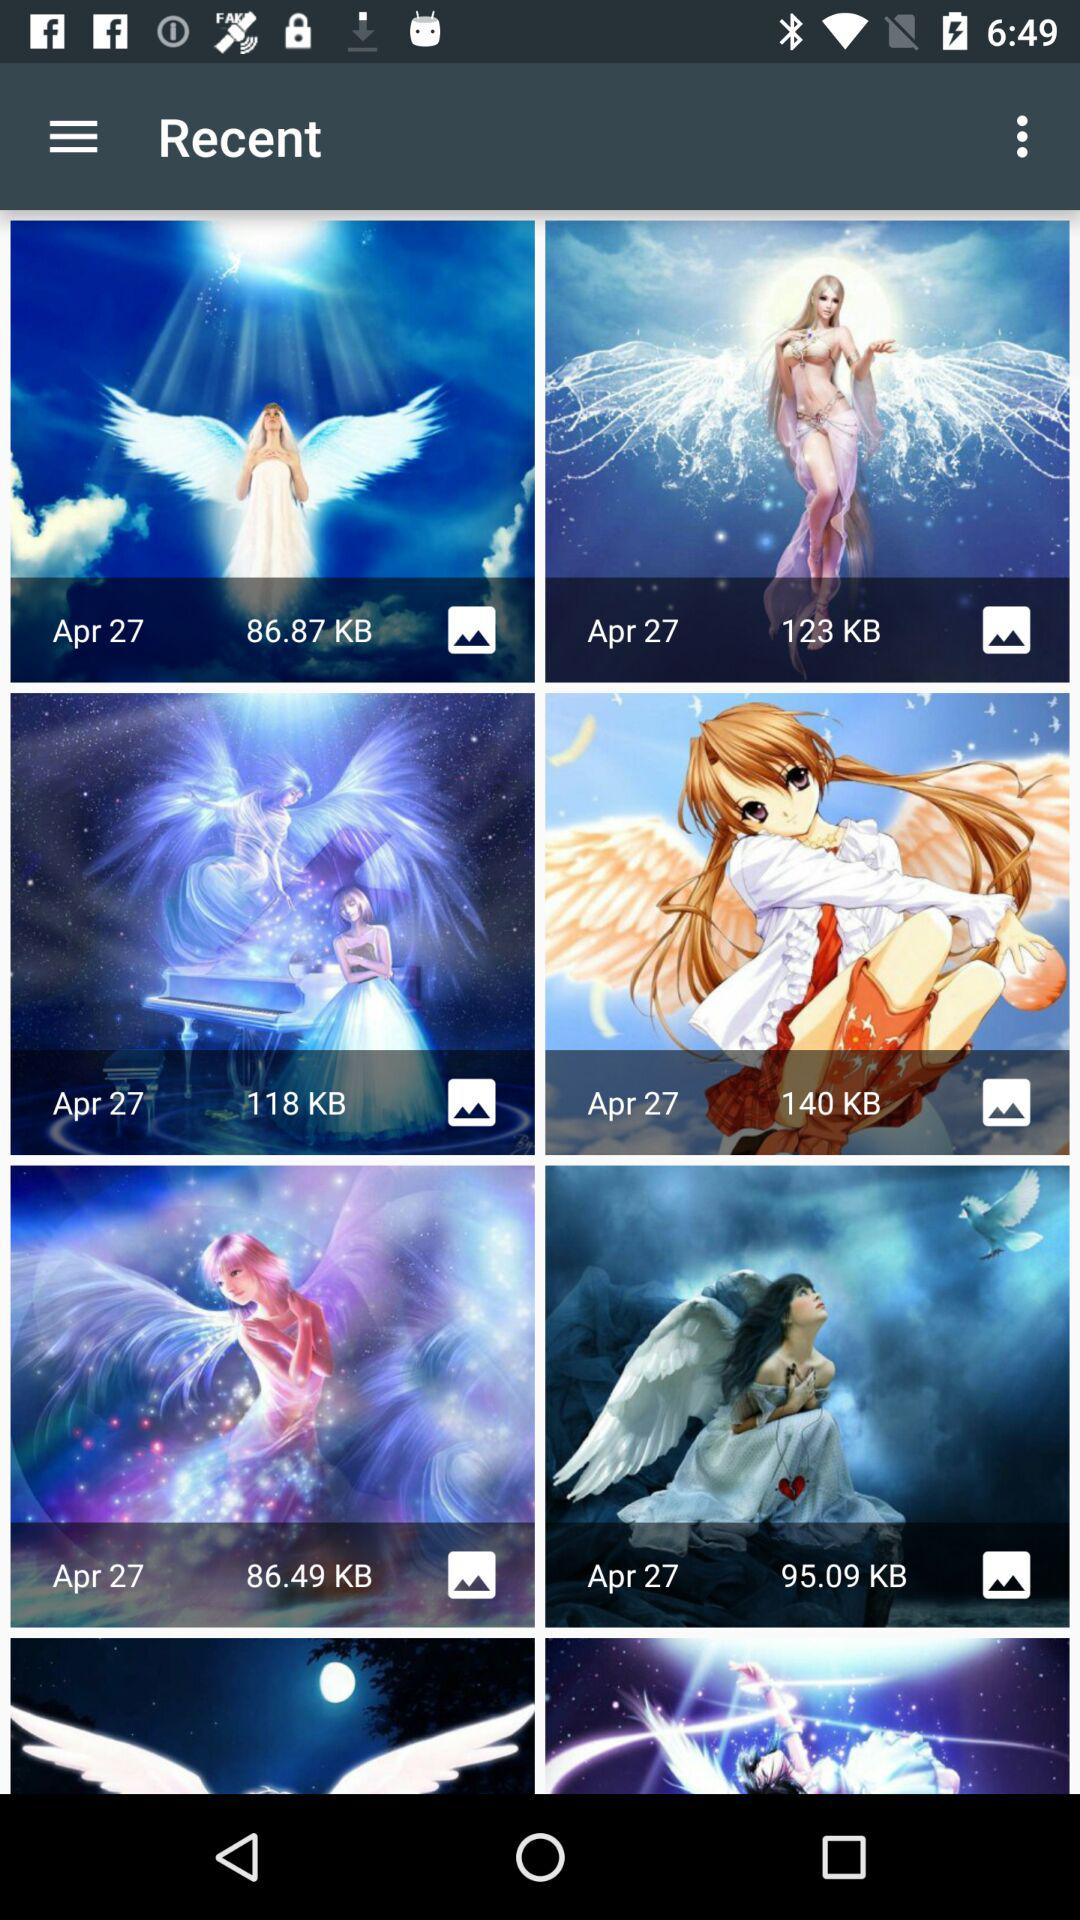How many KB are the sizes of the pictures? The sizes of the pictures are 86.87 KB, 123 KB, 118 KB, 140 KB, 86.49 KB, and 95.09 KB. 